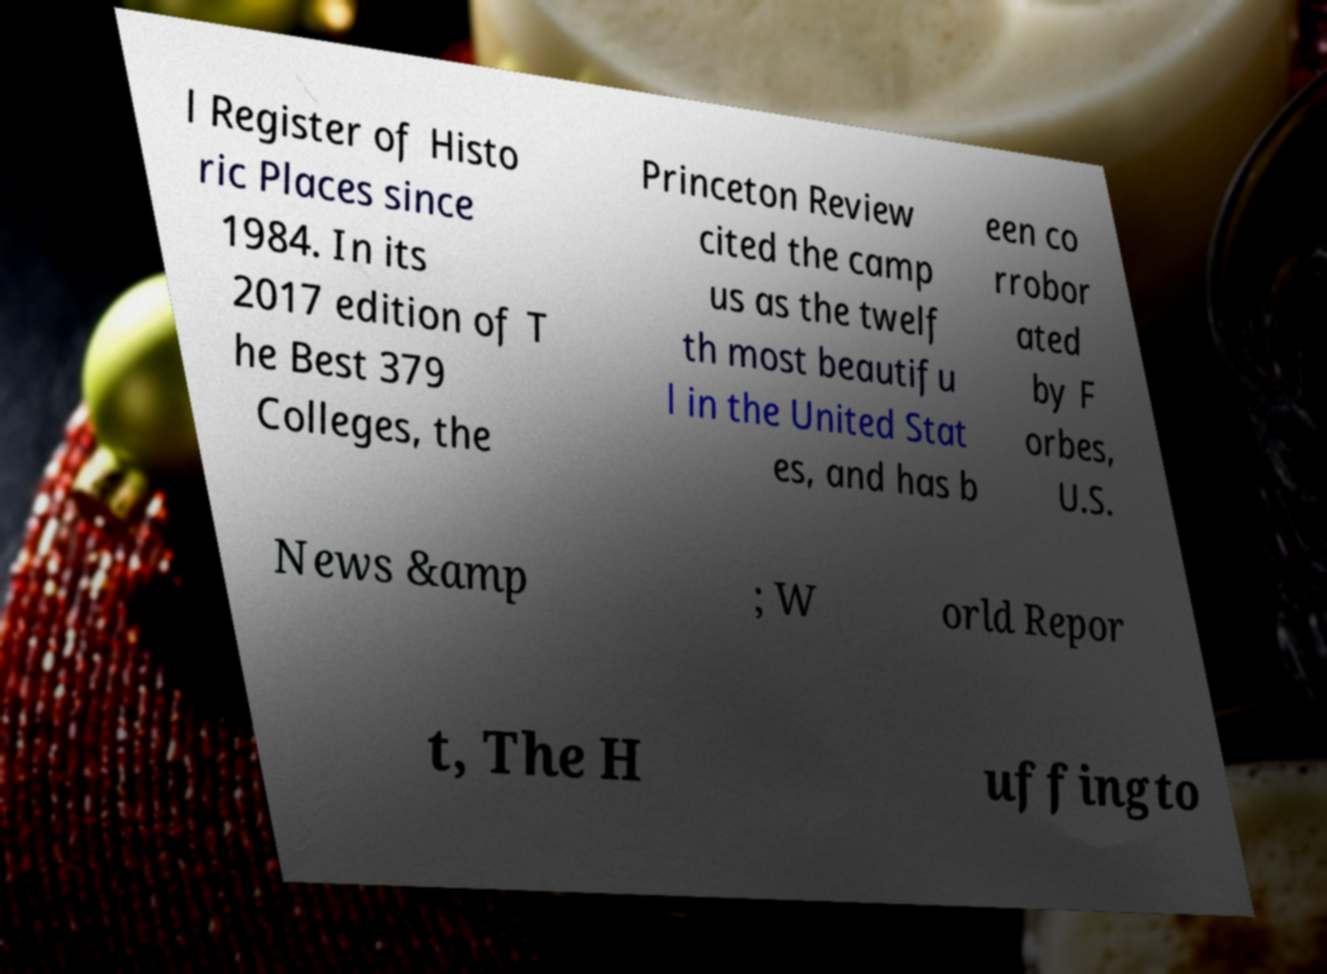There's text embedded in this image that I need extracted. Can you transcribe it verbatim? l Register of Histo ric Places since 1984. In its 2017 edition of T he Best 379 Colleges, the Princeton Review cited the camp us as the twelf th most beautifu l in the United Stat es, and has b een co rrobor ated by F orbes, U.S. News &amp ; W orld Repor t, The H uffingto 